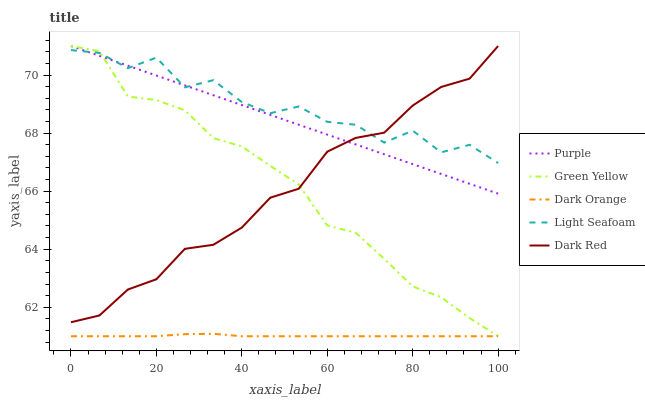Does Dark Orange have the minimum area under the curve?
Answer yes or no. Yes. Does Light Seafoam have the maximum area under the curve?
Answer yes or no. Yes. Does Green Yellow have the minimum area under the curve?
Answer yes or no. No. Does Green Yellow have the maximum area under the curve?
Answer yes or no. No. Is Purple the smoothest?
Answer yes or no. Yes. Is Light Seafoam the roughest?
Answer yes or no. Yes. Is Dark Orange the smoothest?
Answer yes or no. No. Is Dark Orange the roughest?
Answer yes or no. No. Does Dark Orange have the lowest value?
Answer yes or no. Yes. Does Light Seafoam have the lowest value?
Answer yes or no. No. Does Dark Red have the highest value?
Answer yes or no. Yes. Does Dark Orange have the highest value?
Answer yes or no. No. Is Dark Orange less than Dark Red?
Answer yes or no. Yes. Is Purple greater than Dark Orange?
Answer yes or no. Yes. Does Dark Red intersect Purple?
Answer yes or no. Yes. Is Dark Red less than Purple?
Answer yes or no. No. Is Dark Red greater than Purple?
Answer yes or no. No. Does Dark Orange intersect Dark Red?
Answer yes or no. No. 